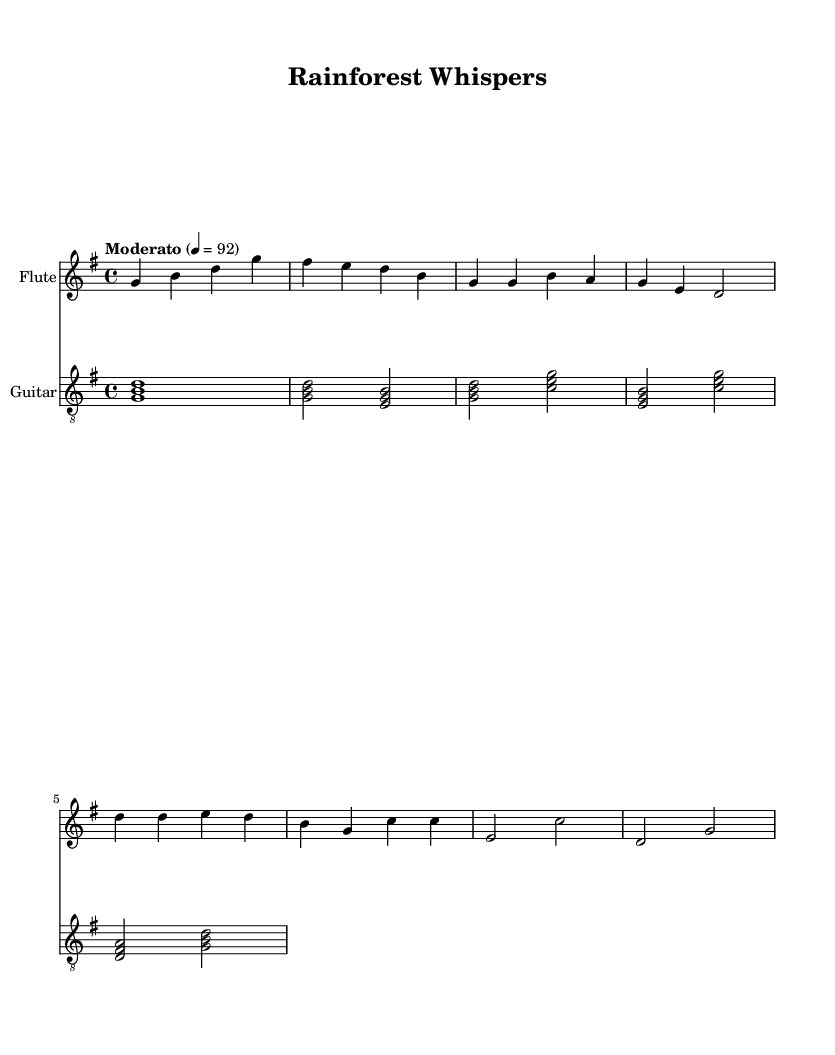What is the key signature of this music? The key signature indicates that the music is in G major, which has one sharp (F sharp). This is denoted at the beginning of the staff where the key signature is shown.
Answer: G major What is the time signature of this music? The time signature of the piece is indicated as 4/4, meaning there are four beats in each measure and a quarter note receives one beat. This is found at the beginning of the score, right after the key signature.
Answer: 4/4 What is the tempo marking indicated in the score? The tempo marking states "Moderato" with a metronome marking of 92, which indicates a moderate speed for the piece. This marking is located at the beginning of the music, after the time signature.
Answer: Moderato 92 How many measures are in the flute part before the first chorus? By counting the measures notated for the flute in the provided sheet music, up to the first appearance of the chorus, we find that there are a total of 6 measures. This is done by visually identifying the individual measures in the flute staff.
Answer: 6 What is the highest note played in the flute part? The highest note in the flute part is represented by the note D an octave above middle C, which is located in the second measure of the chorus. By analyzing the notes laid out in the staff, we identify this as the highest point.
Answer: D Describe the instrumentation used in this piece. The instrumentation features a flute and a guitar, which are stated at the beginning of the score with their respective staff titles. The staff lines indicate that both instruments play distinct parts but within the same overall composition.
Answer: Flute and Guitar 